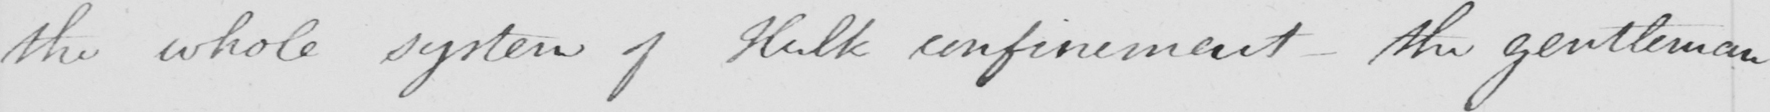Please transcribe the handwritten text in this image. the whole system of Hulk confinement  _  the gentleman 